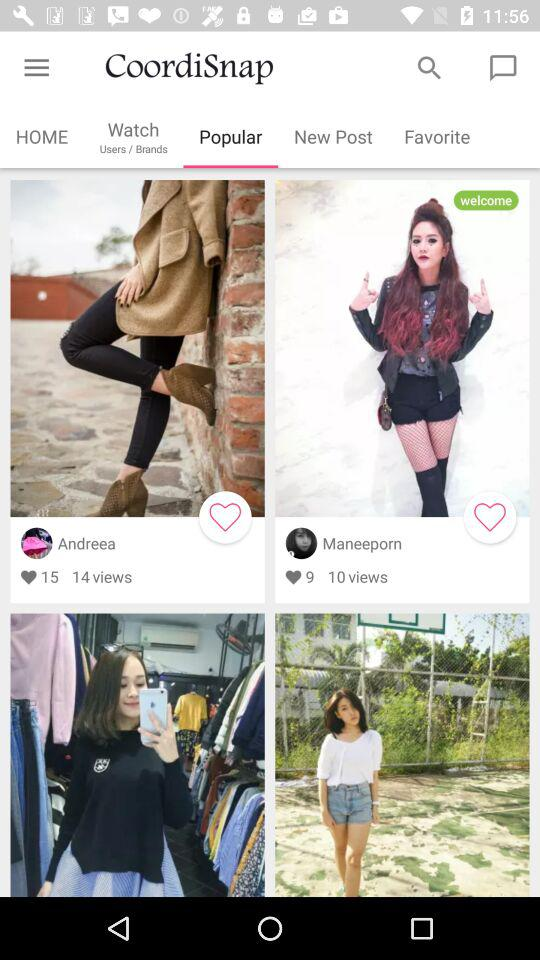What is the total count of views on Andreea's post? The total count of views on Andreea's post is 14. 